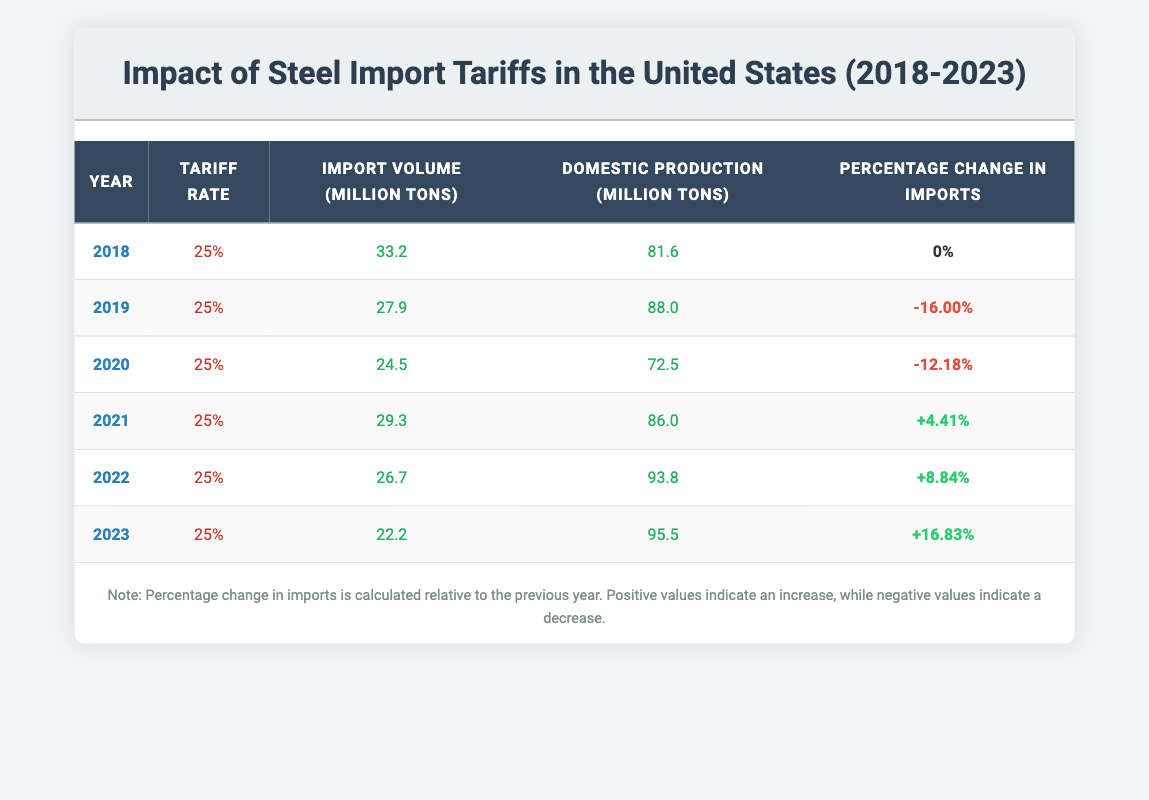What was the import volume of steel in 2018? Refer to the table, under the year 2018, the import volume is listed as 33.2 million tons.
Answer: 33.2 million tons How much did steel import volumes decrease from 2018 to 2019? The import volume in 2018 was 33.2 million tons, and in 2019 it decreased to 27.9 million tons. To find the decrease, subtract: 33.2 - 27.9 = 5.3 million tons.
Answer: 5.3 million tons What was the domestic production of steel in 2023? Looking at the data for the year 2023, the domestic production of steel is listed as 95.5 million tons.
Answer: 95.5 million tons Did the import volume of steel increase from 2020 to 2021? The import volume in 2020 was 24.5 million tons and in 2021 it rose to 29.3 million tons. Since 29.3 is greater than 24.5, this indicates an increase.
Answer: Yes What is the average import volume of steel from 2018 to 2023? To calculate the average, sum the import volumes: 33.2 + 27.9 + 24.5 + 29.3 + 26.7 + 22.2 = 163.8 million tons. There are 6 years (data points), so divide: 163.8 / 6 = 27.3 million tons.
Answer: 27.3 million tons How much did domestic production increase from 2018 to 2022? In 2018, domestic production was 81.6 million tons, and in 2022, it was 93.8 million tons. To find the increase, subtract: 93.8 - 81.6 = 12.2 million tons.
Answer: 12.2 million tons Was there a decrease in steel imports in every year from 2018 to 2023? Observing the data, the import volume decreased from 2018 to 2019, 2019 to 2020, but increased from 2020 to 2021, then decreased again in the subsequent years (2021 to 2022 and 2022 to 2023). Thus, there were years with increases as well.
Answer: No What is the total steel import volume over the years analyzed (2018 to 2023)? The total can be found by adding up all the import volumes: 33.2 + 27.9 + 24.5 + 29.3 + 26.7 + 22.2 = 163.8 million tons.
Answer: 163.8 million tons In which year was the lowest steel import volume recorded? By reviewing the import volumes for the years: 33.2 (2018), 27.9 (2019), 24.5 (2020), 29.3 (2021), 26.7 (2022), and 22.2 (2023), 22.2 million tons in 2023 is the lowest volume recorded.
Answer: 2023 